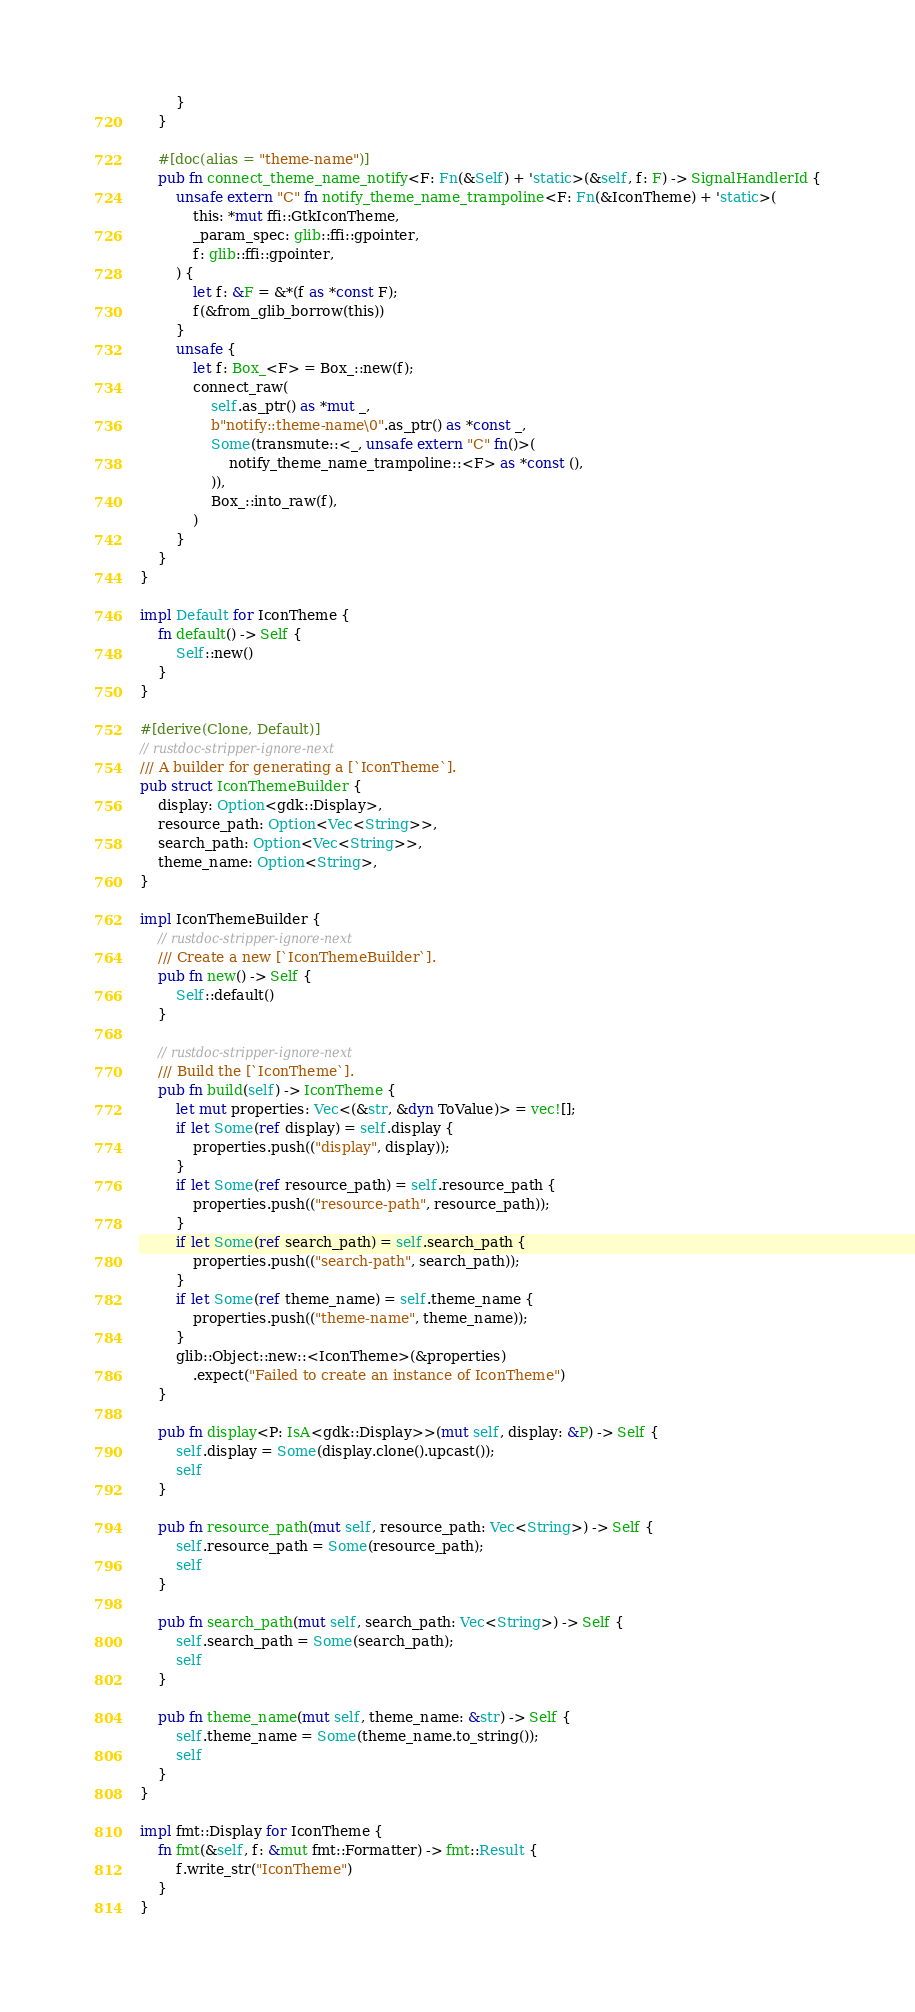<code> <loc_0><loc_0><loc_500><loc_500><_Rust_>        }
    }

    #[doc(alias = "theme-name")]
    pub fn connect_theme_name_notify<F: Fn(&Self) + 'static>(&self, f: F) -> SignalHandlerId {
        unsafe extern "C" fn notify_theme_name_trampoline<F: Fn(&IconTheme) + 'static>(
            this: *mut ffi::GtkIconTheme,
            _param_spec: glib::ffi::gpointer,
            f: glib::ffi::gpointer,
        ) {
            let f: &F = &*(f as *const F);
            f(&from_glib_borrow(this))
        }
        unsafe {
            let f: Box_<F> = Box_::new(f);
            connect_raw(
                self.as_ptr() as *mut _,
                b"notify::theme-name\0".as_ptr() as *const _,
                Some(transmute::<_, unsafe extern "C" fn()>(
                    notify_theme_name_trampoline::<F> as *const (),
                )),
                Box_::into_raw(f),
            )
        }
    }
}

impl Default for IconTheme {
    fn default() -> Self {
        Self::new()
    }
}

#[derive(Clone, Default)]
// rustdoc-stripper-ignore-next
/// A builder for generating a [`IconTheme`].
pub struct IconThemeBuilder {
    display: Option<gdk::Display>,
    resource_path: Option<Vec<String>>,
    search_path: Option<Vec<String>>,
    theme_name: Option<String>,
}

impl IconThemeBuilder {
    // rustdoc-stripper-ignore-next
    /// Create a new [`IconThemeBuilder`].
    pub fn new() -> Self {
        Self::default()
    }

    // rustdoc-stripper-ignore-next
    /// Build the [`IconTheme`].
    pub fn build(self) -> IconTheme {
        let mut properties: Vec<(&str, &dyn ToValue)> = vec![];
        if let Some(ref display) = self.display {
            properties.push(("display", display));
        }
        if let Some(ref resource_path) = self.resource_path {
            properties.push(("resource-path", resource_path));
        }
        if let Some(ref search_path) = self.search_path {
            properties.push(("search-path", search_path));
        }
        if let Some(ref theme_name) = self.theme_name {
            properties.push(("theme-name", theme_name));
        }
        glib::Object::new::<IconTheme>(&properties)
            .expect("Failed to create an instance of IconTheme")
    }

    pub fn display<P: IsA<gdk::Display>>(mut self, display: &P) -> Self {
        self.display = Some(display.clone().upcast());
        self
    }

    pub fn resource_path(mut self, resource_path: Vec<String>) -> Self {
        self.resource_path = Some(resource_path);
        self
    }

    pub fn search_path(mut self, search_path: Vec<String>) -> Self {
        self.search_path = Some(search_path);
        self
    }

    pub fn theme_name(mut self, theme_name: &str) -> Self {
        self.theme_name = Some(theme_name.to_string());
        self
    }
}

impl fmt::Display for IconTheme {
    fn fmt(&self, f: &mut fmt::Formatter) -> fmt::Result {
        f.write_str("IconTheme")
    }
}
</code> 